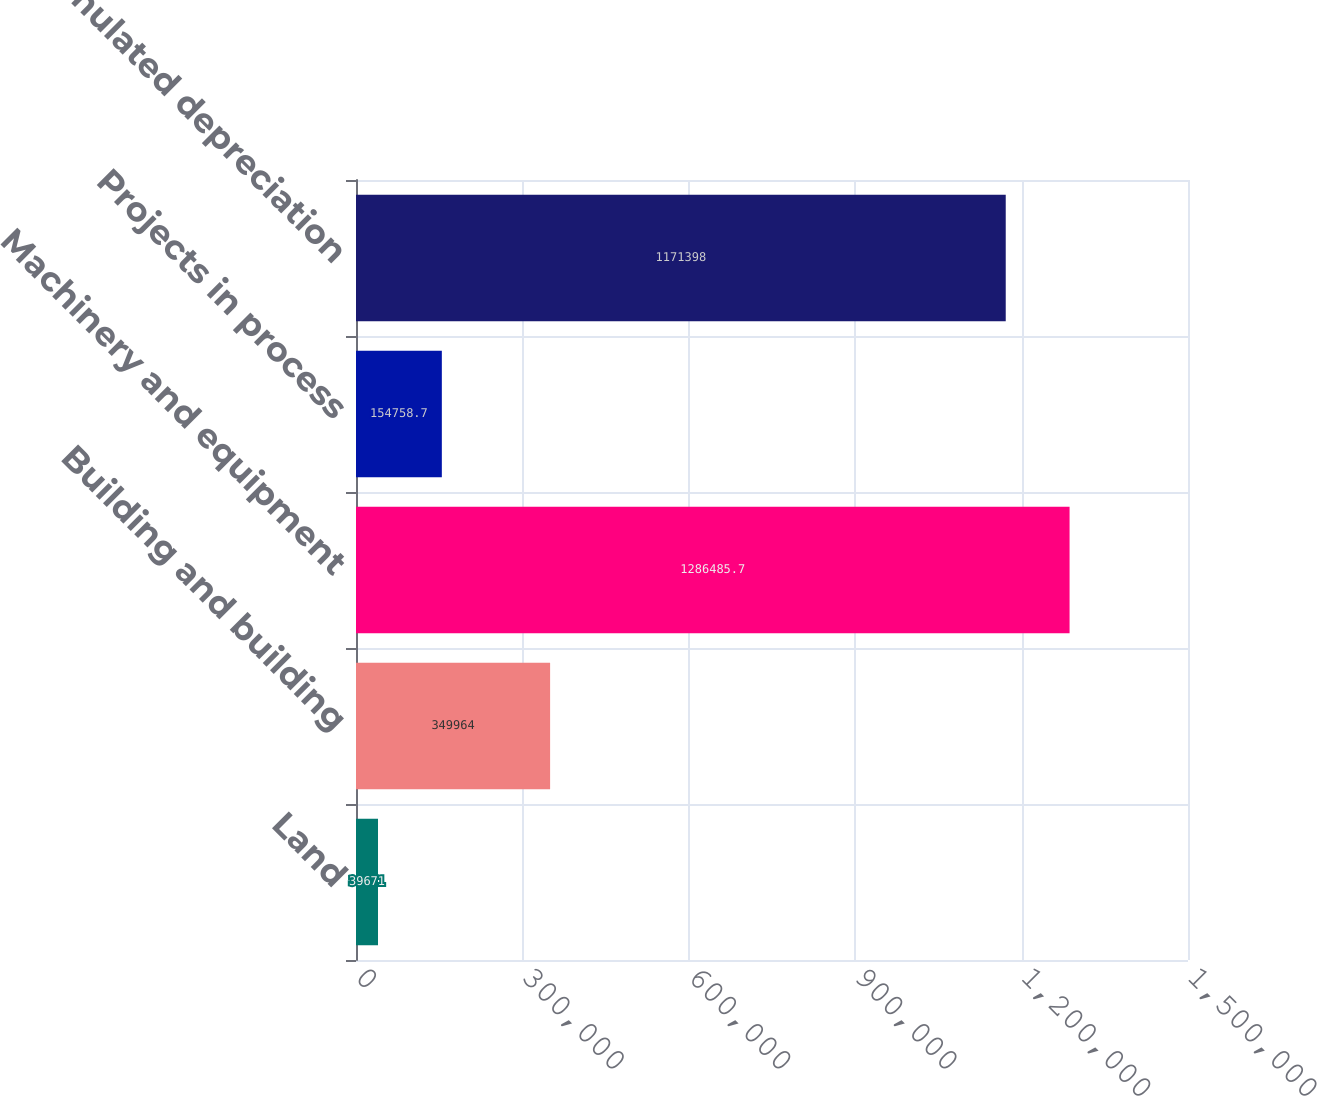Convert chart to OTSL. <chart><loc_0><loc_0><loc_500><loc_500><bar_chart><fcel>Land<fcel>Building and building<fcel>Machinery and equipment<fcel>Projects in process<fcel>Less accumulated depreciation<nl><fcel>39671<fcel>349964<fcel>1.28649e+06<fcel>154759<fcel>1.1714e+06<nl></chart> 